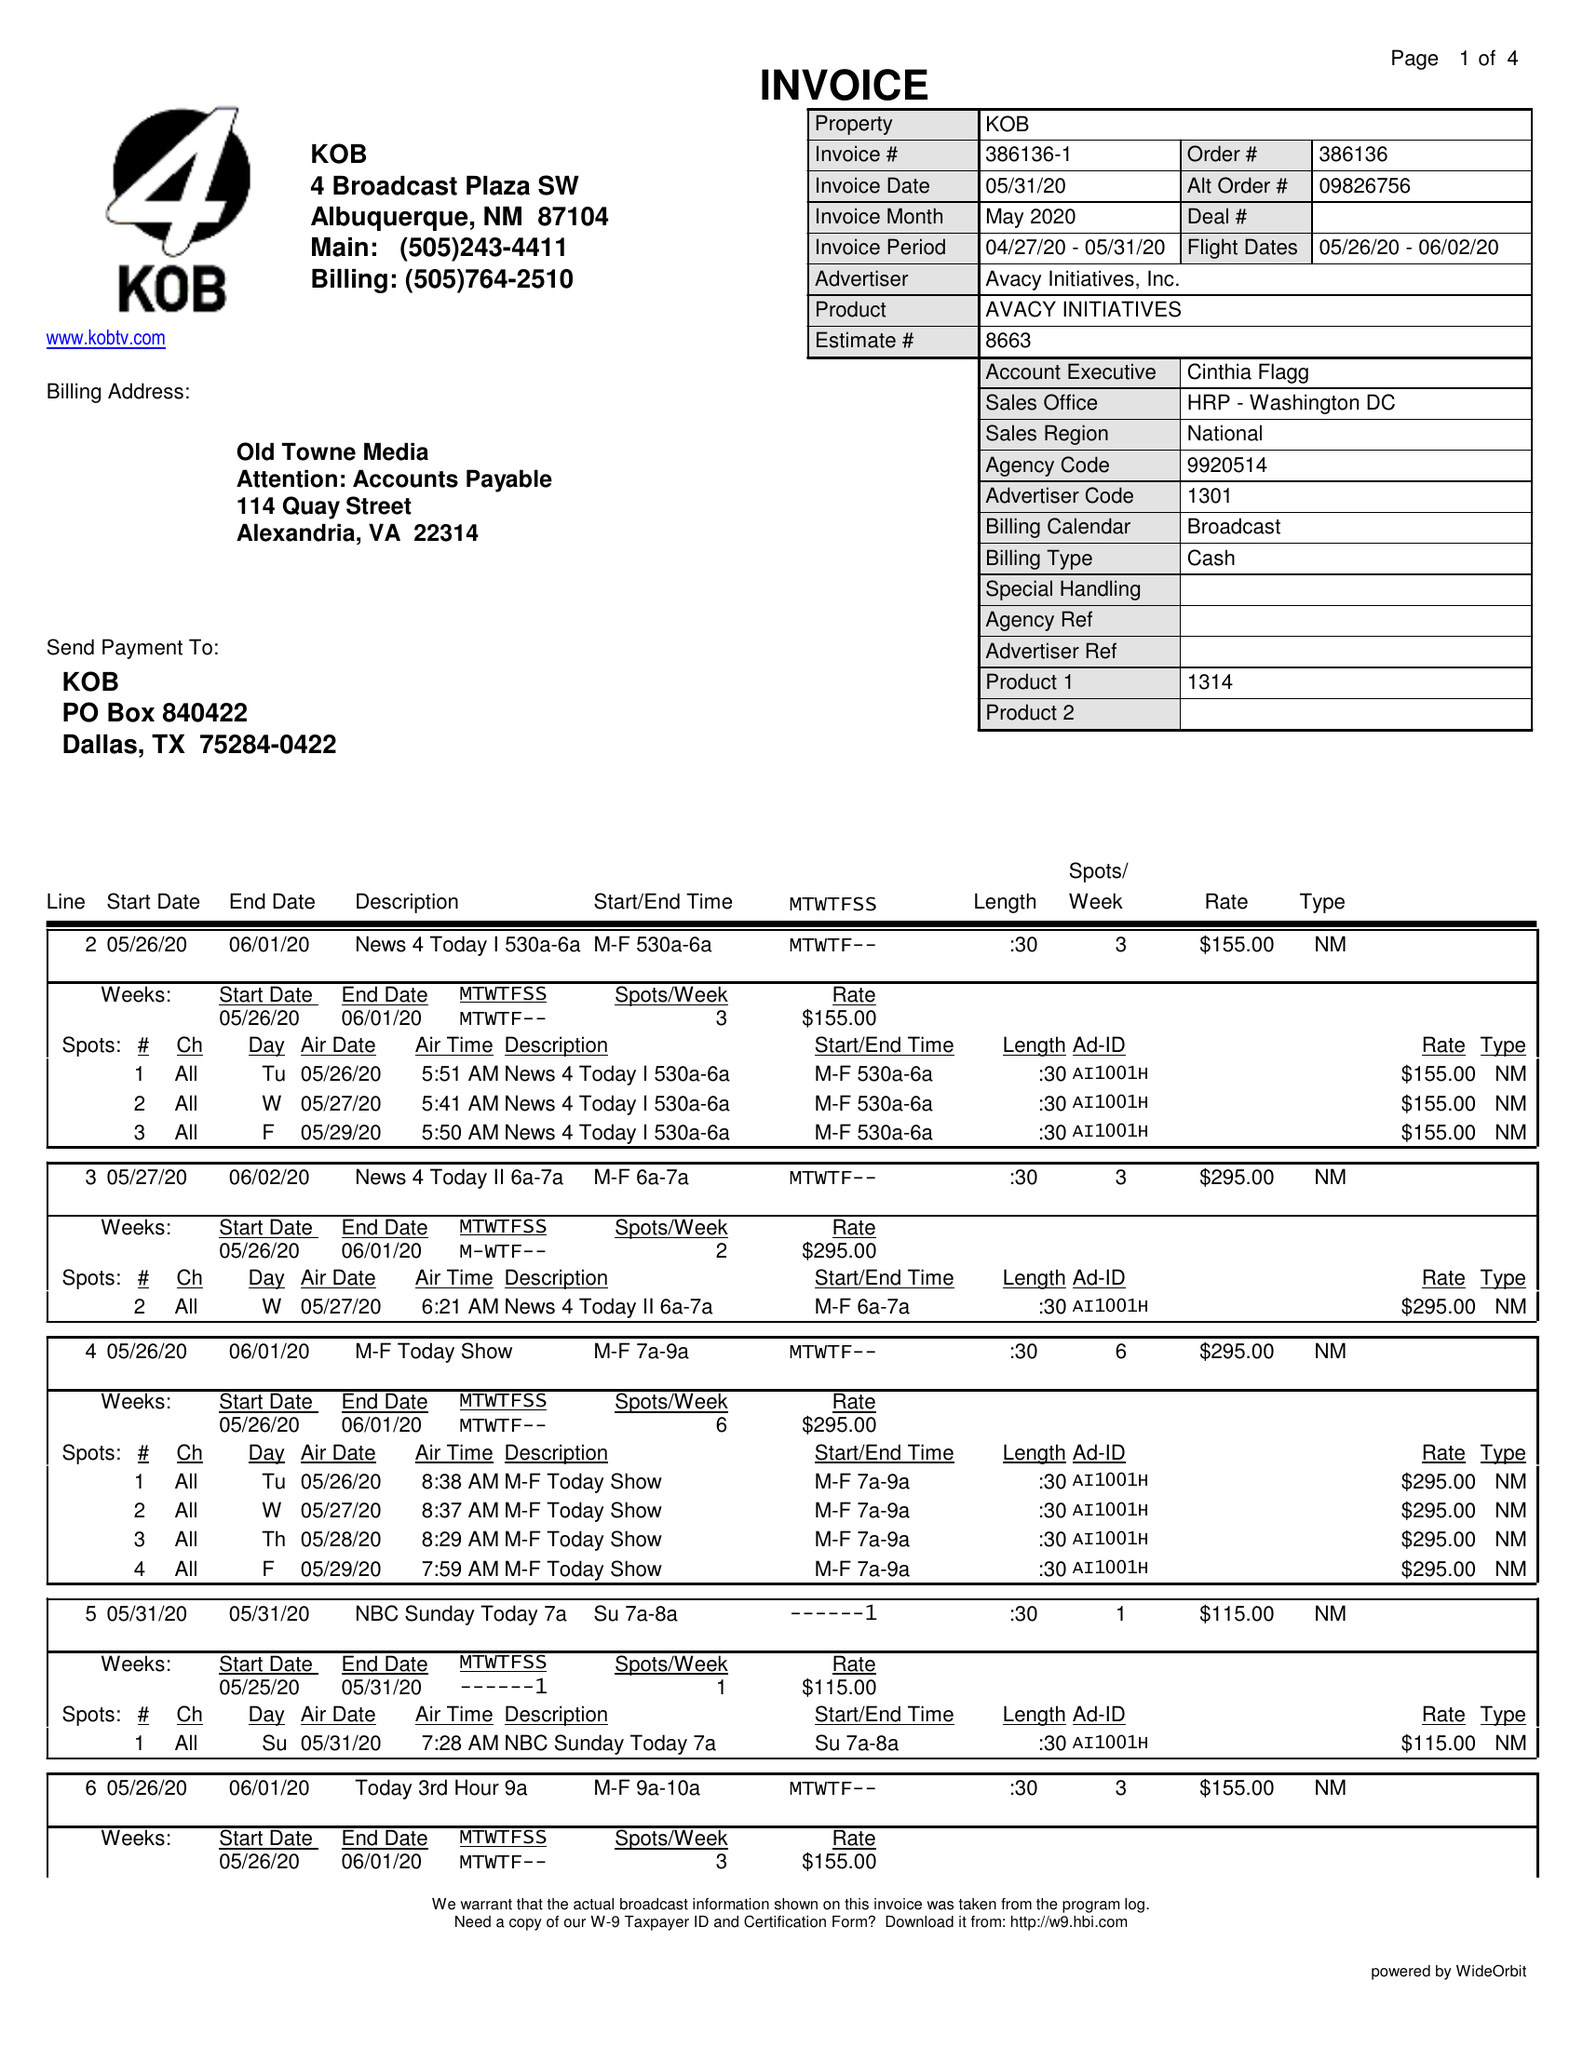What is the value for the advertiser?
Answer the question using a single word or phrase. AVACY INITIATIVES, INC. 